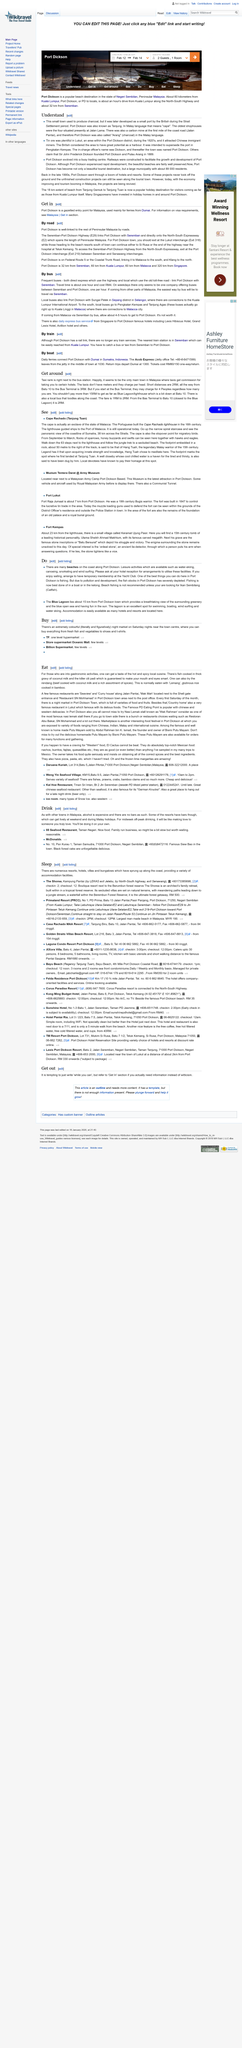Indicate a few pertinent items in this graphic. In Malaysia, alcohol is generally expensive and difficult to obtain in most towns. While some resorts have bars that are lively during the weekends and on Malay holidays, there are no true bars in most areas. Fishing is considered one of the best activities to do in Port Dickson. Accommodation is readily available at the Blue Lagoon. In Malaysia, there are no bars as such, and alcohol is expensive. However, some resorts have bars that become lively during weekends and Malay holidays. What is the E number for the Seremban-Port Dickson Highway? It is 29. 